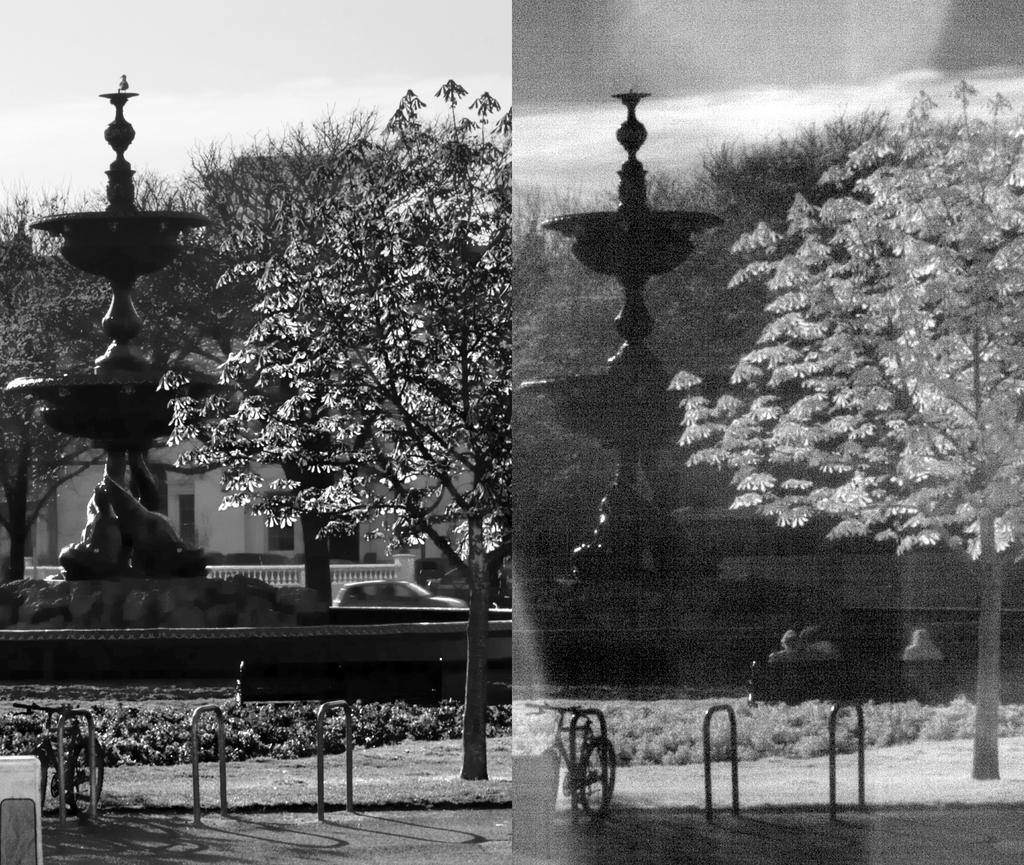What is the main subject of the collage in the image? The image is a collage of the same picture, so the main subject is a fountain. What can be seen on the road in the image? There is a bicycle on the road in the image. What type of structure is present in the image? Iron rods are present in the image. What type of vegetation is in the image? There is a tree in the image. What is visible in the background of the image? There is a building, trees, and the sky visible in the background of the image. How many boats are visible in the image? There are no boats present in the image. What type of lace is used to decorate the curtain in the image? There is no curtain present in the image. 